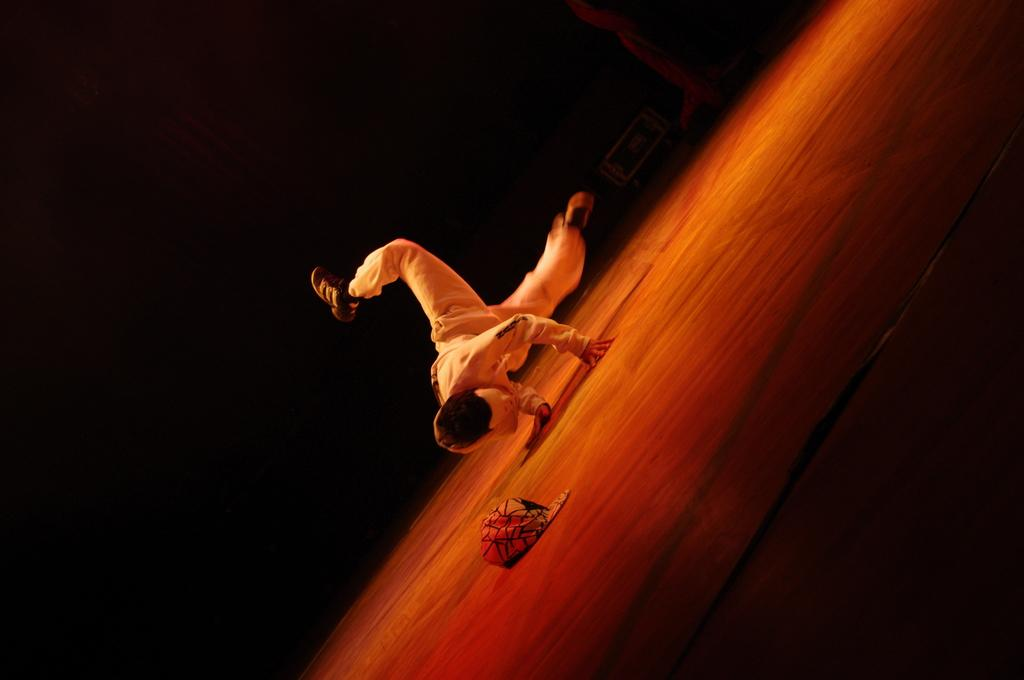What is the main subject of the image? There is a person in the image. What object can be seen on the floor in the image? There is a cap on the floor in the image. What color is the background of the image? The background of the image is black in color. What type of dock can be seen in the image? There is no dock present in the image. What material is the canvas made of in the image? There is no canvas present in the image. 